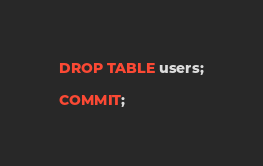<code> <loc_0><loc_0><loc_500><loc_500><_SQL_>DROP TABLE users;

COMMIT;
</code> 